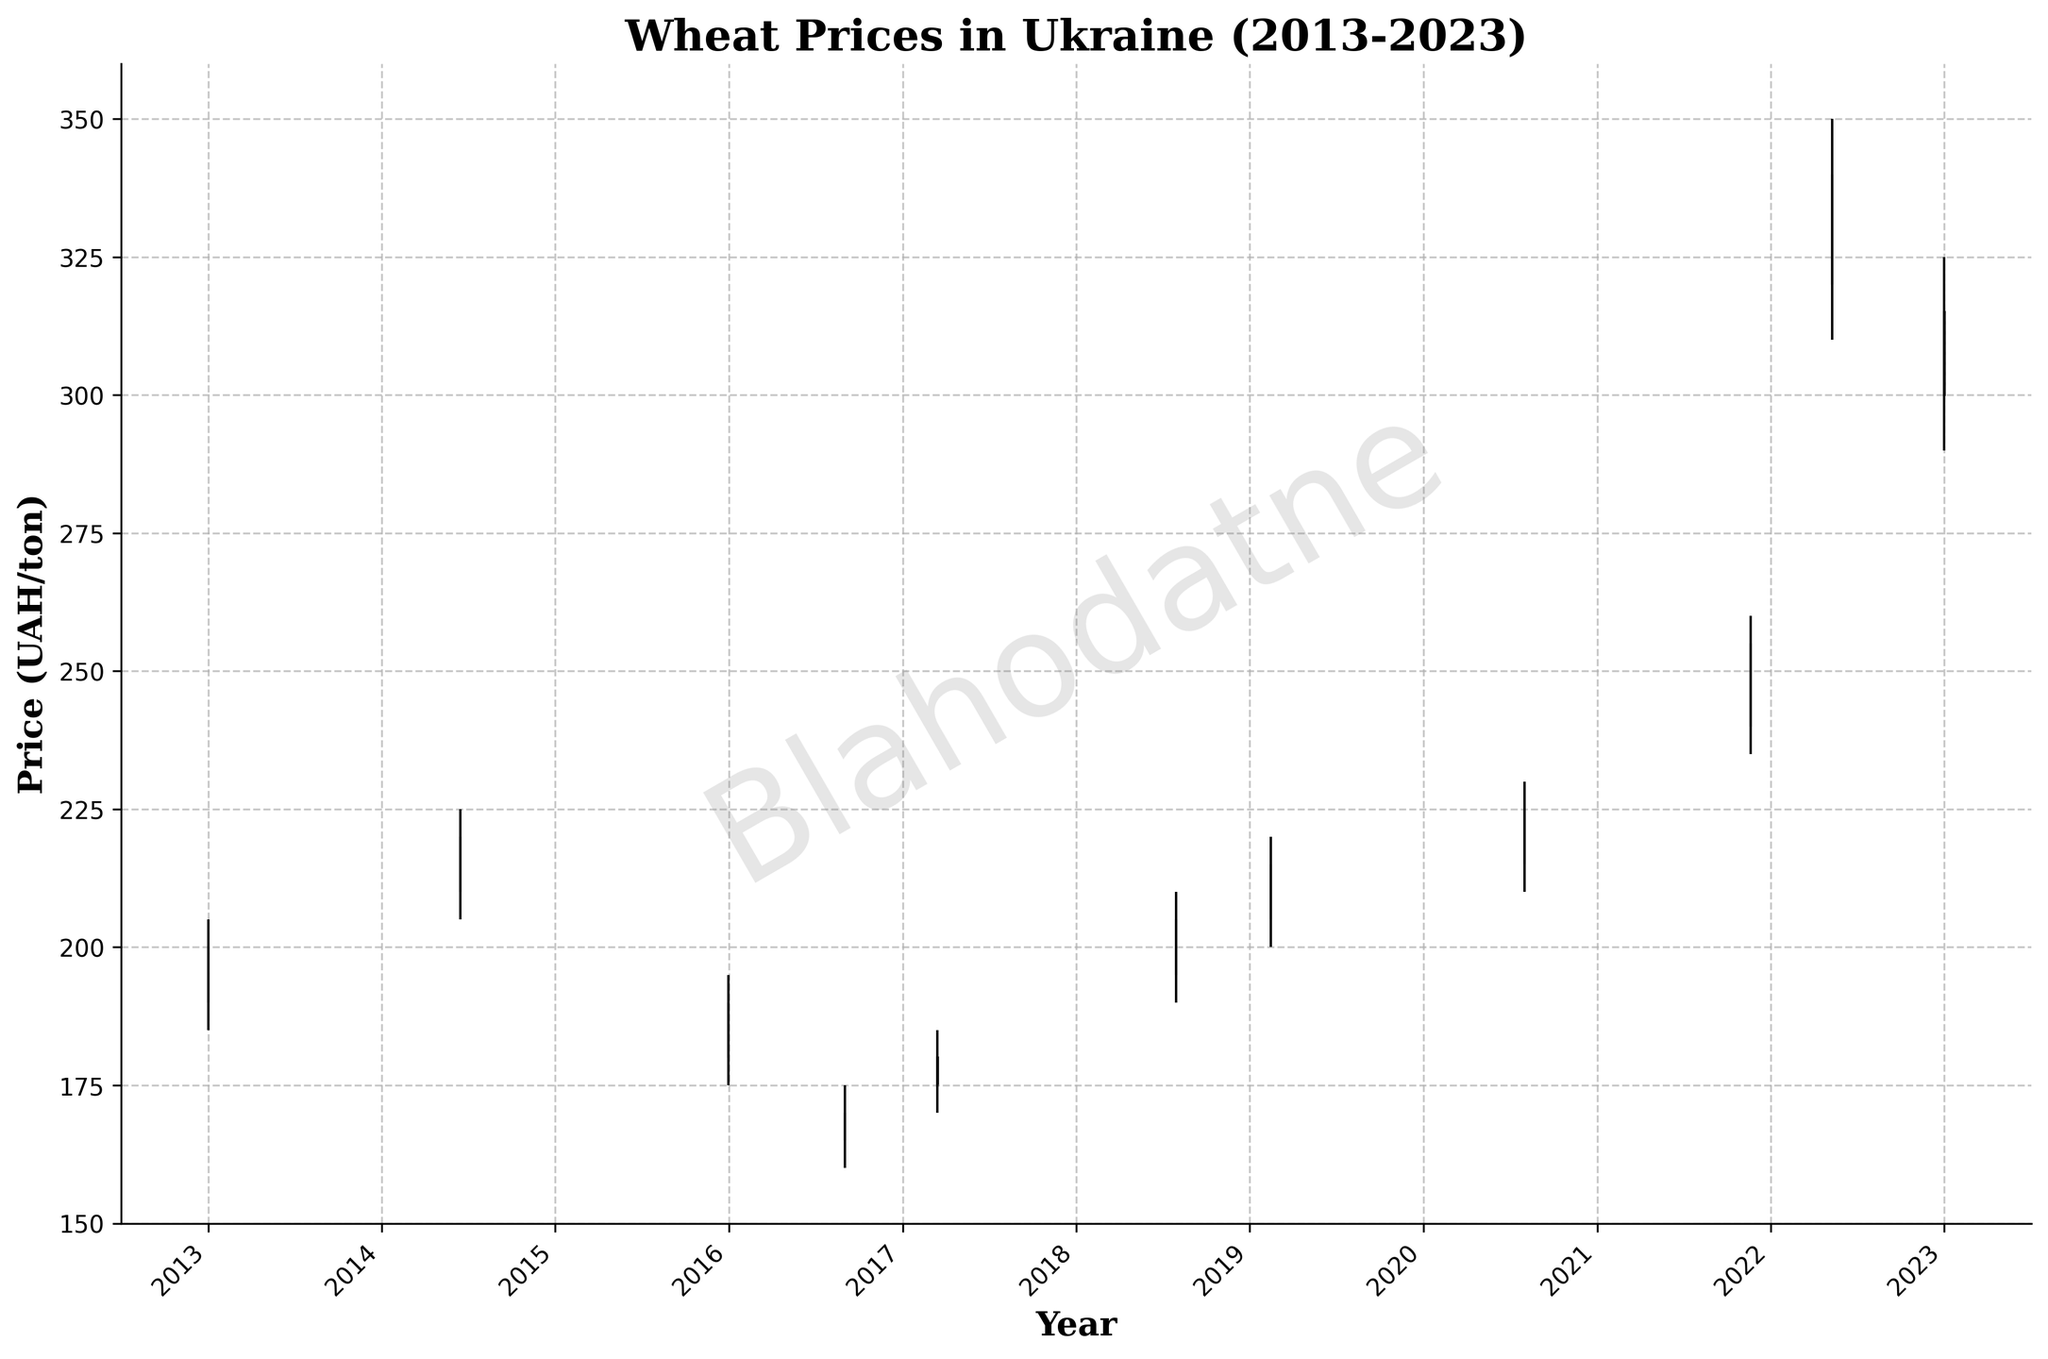What is the title of the plot? The title of the plot is displayed at the top of the figure. It provides a brief description of what the plot represents. In this case, the title states "Wheat Prices in Ukraine (2013-2023)".
Answer: Wheat Prices in Ukraine (2013-2023) How many data points are there in the plot? By counting the number of OHLC bars in the chart, you can determine the number of data points. Each bar corresponds to one data point.
Answer: 11 What is the highest price recorded for wheat in this plot? The highest price can be identified by looking at the highest vertical line among the OHLC bars. The highest vertical line reaches up to 350 UAH/ton on 2022-05-10.
Answer: 350 UAH/ton Which year had the lowest closing price for wheat? To determine the year with the lowest closing price, locate the lowest closing value among the OHLC bars. This can be observed to be in the year 2016 with a closing price of 170 UAH/ton.
Answer: 2016 What is the range of wheat prices in 2022? The range is calculated by subtracting the lowest price from the highest price within the year 2022. For 2022, the highest price is 350 UAH/ton and the lowest is 310 UAH/ton. The range is 350 - 310 = 40 UAH/ton.
Answer: 40 UAH/ton In which years did the closing price of wheat increase as compared to the opening price? To find the years where the closing price is higher than the opening price, compare the closing and opening prices for each year. Identify the years where Close > Open: 2013, 2014, 2015, 2018, 2019, 2020, 2021, 2022, 2023.
Answer: 2013, 2014, 2018, 2019, 2020, 2021, 2022, 2023 What is the difference between the closing price in 2021 and 2023? The closing prices for 2021 and 2023 are 255 UAH/ton and 315 UAH/ton, respectively. Subtract the closing price of 2021 from 2023: 315 - 255 = 60 UAH/ton.
Answer: 60 UAH/ton How many years show a decrease in the opening price compared to the previous year's closing price? To find the number of years with decreasing opening prices compared to the previous year's closing price, check the opening price of each year and compare it with the previous year's closing price. 2015 (180 vs 220 of 2014), 2016 (165 vs 190 of 2015), 2017 (175 vs 170 of 2016), 2018 (195 vs 180 of 2017).
Answer: 4 years 